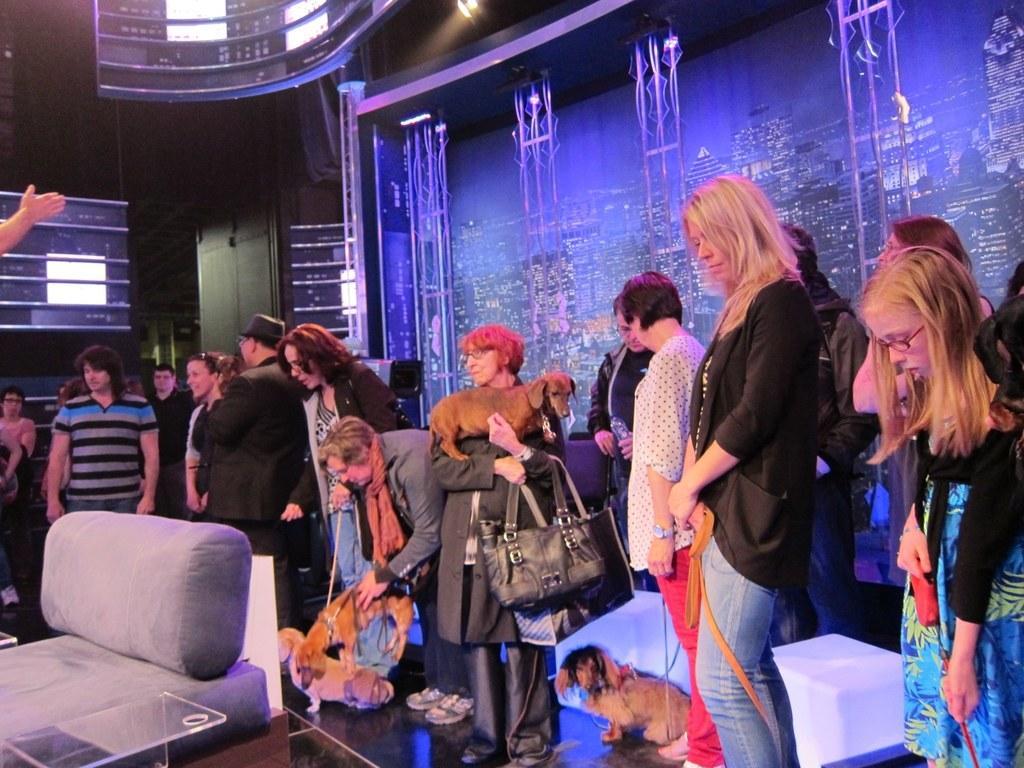Describe this image in one or two sentences. In this image I can see group of people some are standing and some are sitting, the person in front wearing black jacket and black color bag. Background I can see few glasses and I can see blue color lights. 